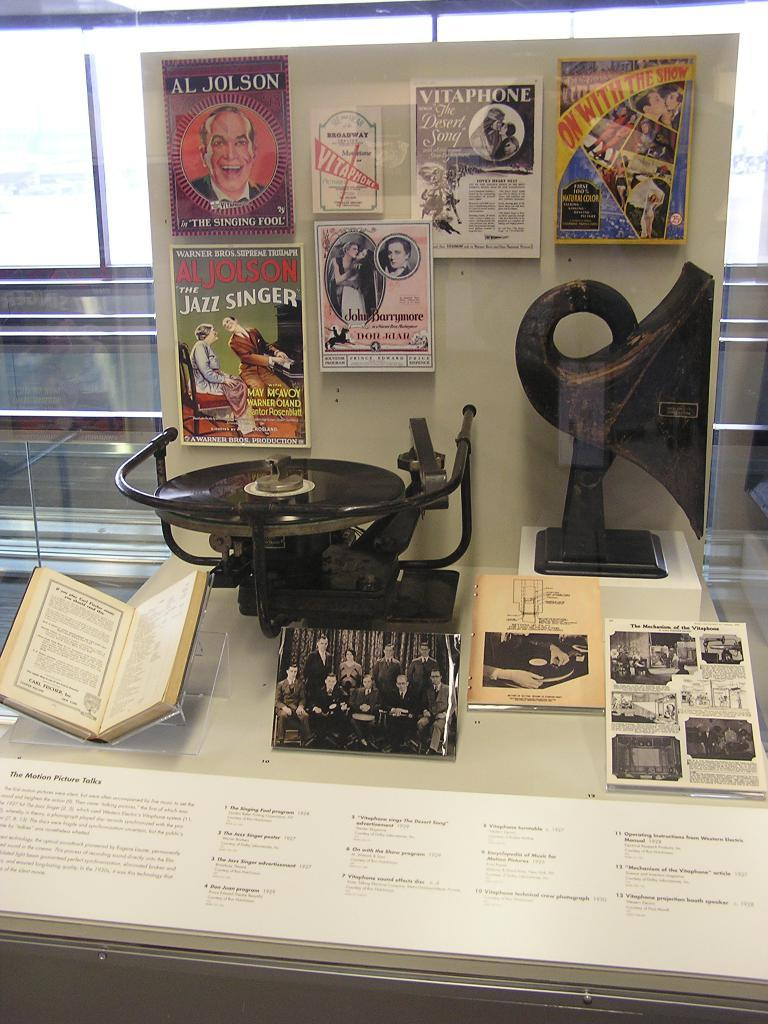<image>
Share a concise interpretation of the image provided. A clear cass displays a card with Al Jolson and the singing fool. 